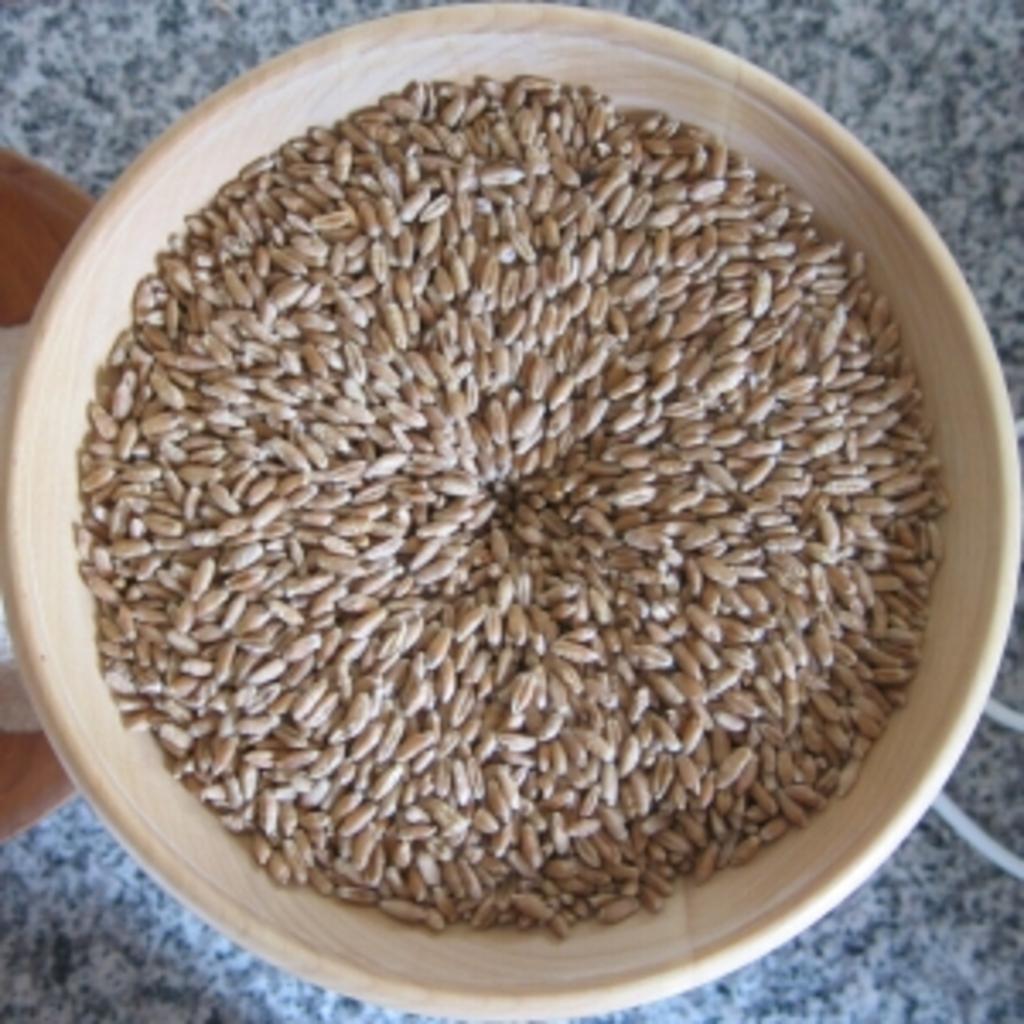Please provide a concise description of this image. In this image we can see wheat in a bowl which is on a platform. On the left side of the image we can see an object which is truncated. 